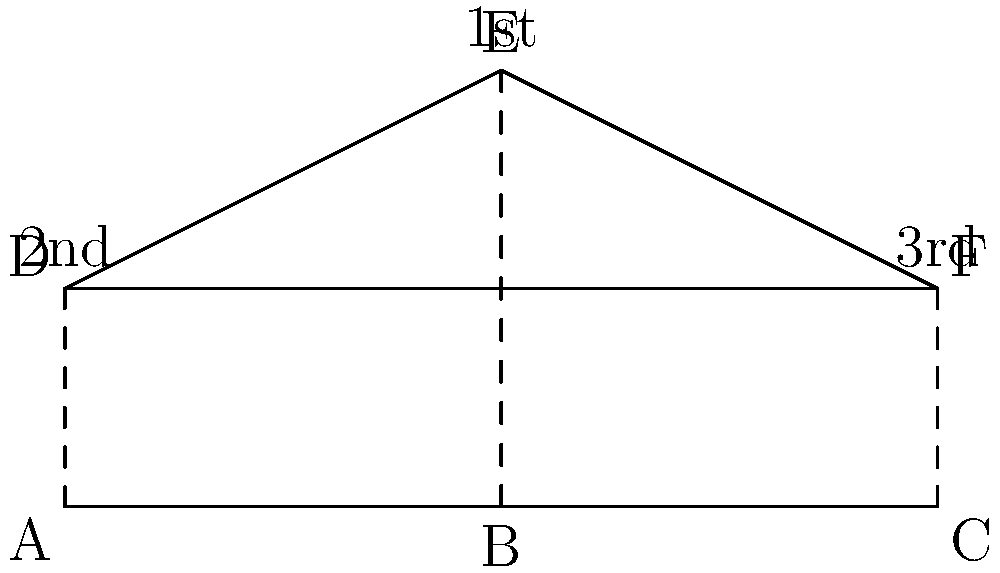As a champion athlete, you're analyzing a new medal podium design. The current podium ABC is transformed into DEF by raising each point. If the height increase for the 2nd place (point A to D) is 1 unit, and for the 3rd place (point C to F) is also 1 unit, how many units must the 1st place podium (point B to E) be raised to maintain the same ranking order while creating a straight line DEF? Let's approach this step-by-step:

1) In the original podium ABC, all points are on the same level (y=0).

2) After transformation:
   - Point A (2nd place) moves up 1 unit to D (0,1)
   - Point C (3rd place) moves up 1 unit to F (4,1)
   - Point B (1st place) moves up x units to E (2,x)

3) For DEF to form a straight line, these points must satisfy the equation of a line.

4) We can use the point-slope form of a line equation:
   $$(y - y_1) = m(x - x_1)$$
   where m is the slope.

5) The slope m can be calculated using D and F:
   $$m = \frac{1-1}{4-0} = 0$$

6) Now, using the point-slope form with D(0,1) and E(2,x):
   $$(x - 1) = 0(2 - 0)$$
   $$x - 1 = 0$$
   $$x = 1$$

7) Therefore, point B must be raised 2 units to point E(2,2) to maintain the ranking order and create a straight line DEF.

This solution ensures that the 1st place remains higher than both 2nd and 3rd, while all three points form a straight line.
Answer: 2 units 